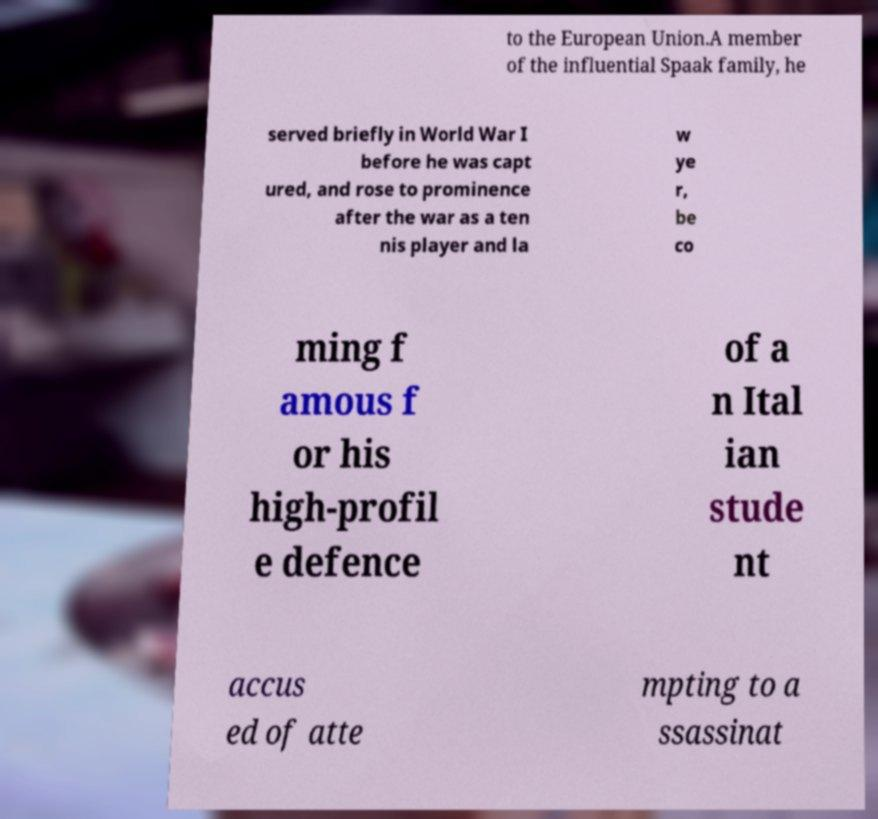Could you extract and type out the text from this image? to the European Union.A member of the influential Spaak family, he served briefly in World War I before he was capt ured, and rose to prominence after the war as a ten nis player and la w ye r, be co ming f amous f or his high-profil e defence of a n Ital ian stude nt accus ed of atte mpting to a ssassinat 